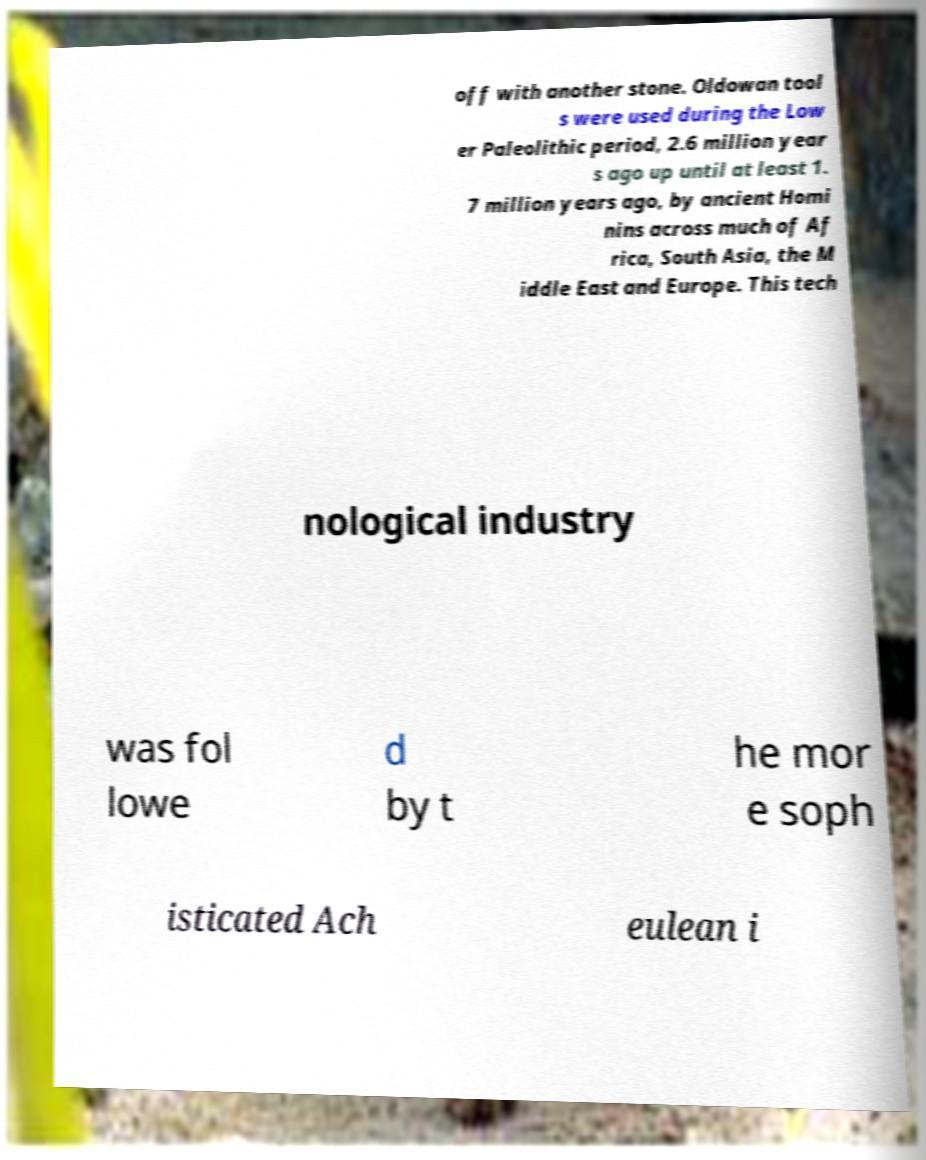I need the written content from this picture converted into text. Can you do that? off with another stone. Oldowan tool s were used during the Low er Paleolithic period, 2.6 million year s ago up until at least 1. 7 million years ago, by ancient Homi nins across much of Af rica, South Asia, the M iddle East and Europe. This tech nological industry was fol lowe d by t he mor e soph isticated Ach eulean i 